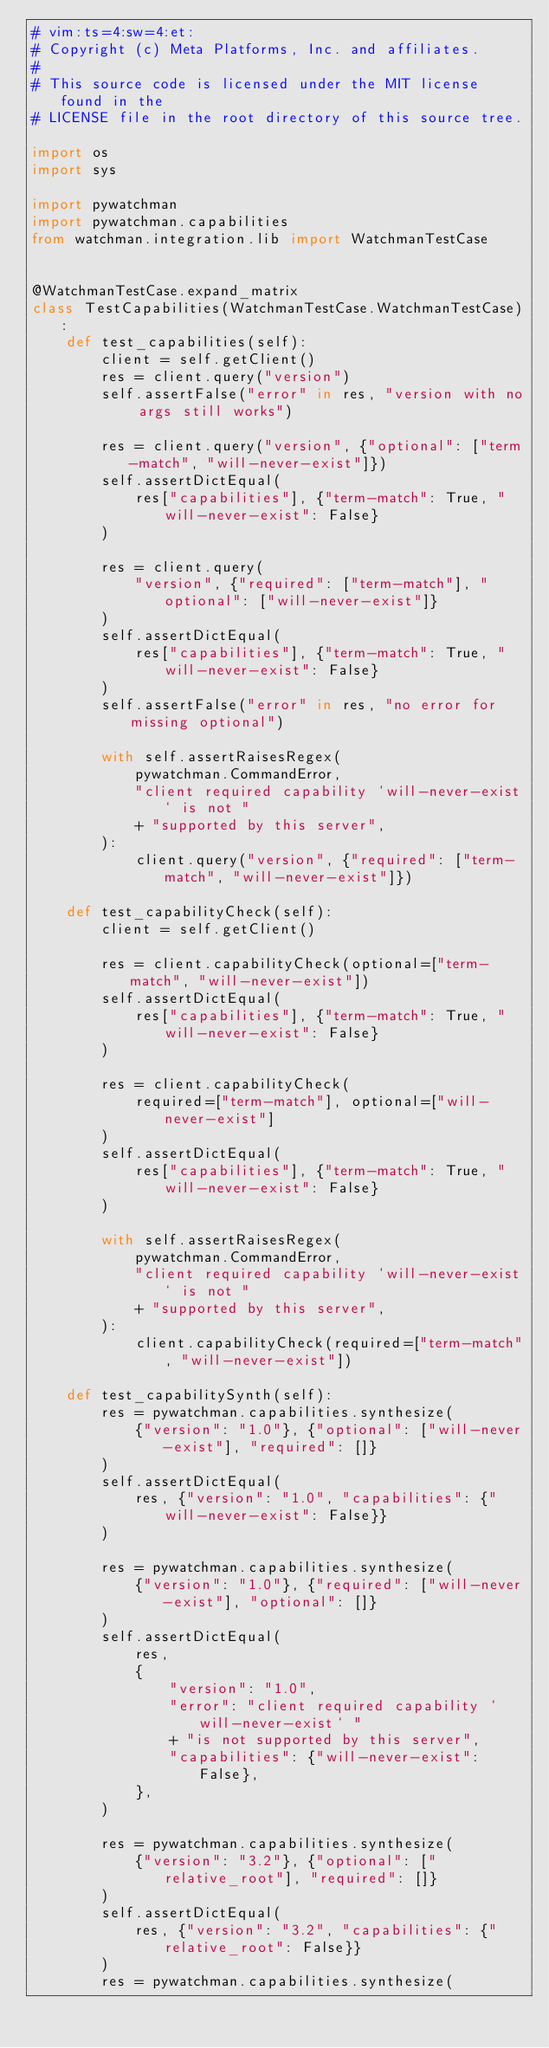<code> <loc_0><loc_0><loc_500><loc_500><_Python_># vim:ts=4:sw=4:et:
# Copyright (c) Meta Platforms, Inc. and affiliates.
#
# This source code is licensed under the MIT license found in the
# LICENSE file in the root directory of this source tree.

import os
import sys

import pywatchman
import pywatchman.capabilities
from watchman.integration.lib import WatchmanTestCase


@WatchmanTestCase.expand_matrix
class TestCapabilities(WatchmanTestCase.WatchmanTestCase):
    def test_capabilities(self):
        client = self.getClient()
        res = client.query("version")
        self.assertFalse("error" in res, "version with no args still works")

        res = client.query("version", {"optional": ["term-match", "will-never-exist"]})
        self.assertDictEqual(
            res["capabilities"], {"term-match": True, "will-never-exist": False}
        )

        res = client.query(
            "version", {"required": ["term-match"], "optional": ["will-never-exist"]}
        )
        self.assertDictEqual(
            res["capabilities"], {"term-match": True, "will-never-exist": False}
        )
        self.assertFalse("error" in res, "no error for missing optional")

        with self.assertRaisesRegex(
            pywatchman.CommandError,
            "client required capability `will-never-exist` is not "
            + "supported by this server",
        ):
            client.query("version", {"required": ["term-match", "will-never-exist"]})

    def test_capabilityCheck(self):
        client = self.getClient()

        res = client.capabilityCheck(optional=["term-match", "will-never-exist"])
        self.assertDictEqual(
            res["capabilities"], {"term-match": True, "will-never-exist": False}
        )

        res = client.capabilityCheck(
            required=["term-match"], optional=["will-never-exist"]
        )
        self.assertDictEqual(
            res["capabilities"], {"term-match": True, "will-never-exist": False}
        )

        with self.assertRaisesRegex(
            pywatchman.CommandError,
            "client required capability `will-never-exist` is not "
            + "supported by this server",
        ):
            client.capabilityCheck(required=["term-match", "will-never-exist"])

    def test_capabilitySynth(self):
        res = pywatchman.capabilities.synthesize(
            {"version": "1.0"}, {"optional": ["will-never-exist"], "required": []}
        )
        self.assertDictEqual(
            res, {"version": "1.0", "capabilities": {"will-never-exist": False}}
        )

        res = pywatchman.capabilities.synthesize(
            {"version": "1.0"}, {"required": ["will-never-exist"], "optional": []}
        )
        self.assertDictEqual(
            res,
            {
                "version": "1.0",
                "error": "client required capability `will-never-exist` "
                + "is not supported by this server",
                "capabilities": {"will-never-exist": False},
            },
        )

        res = pywatchman.capabilities.synthesize(
            {"version": "3.2"}, {"optional": ["relative_root"], "required": []}
        )
        self.assertDictEqual(
            res, {"version": "3.2", "capabilities": {"relative_root": False}}
        )
        res = pywatchman.capabilities.synthesize(</code> 